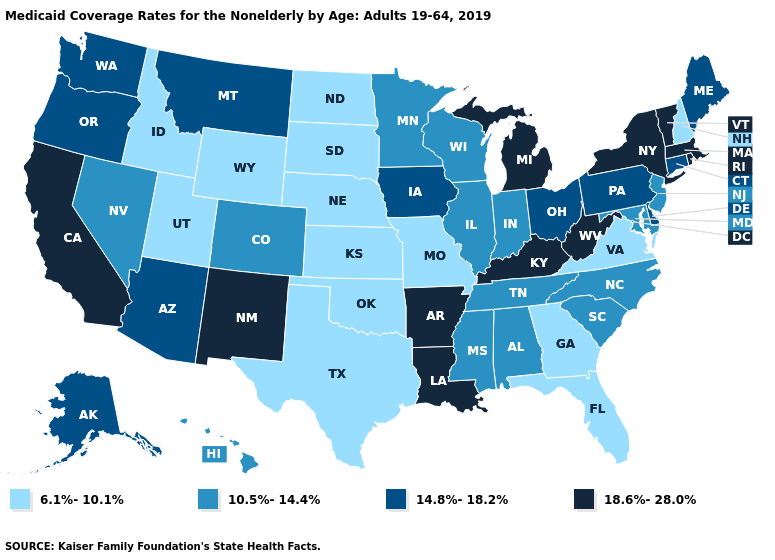Does Texas have the lowest value in the South?
Answer briefly. Yes. What is the highest value in the USA?
Answer briefly. 18.6%-28.0%. Name the states that have a value in the range 14.8%-18.2%?
Be succinct. Alaska, Arizona, Connecticut, Delaware, Iowa, Maine, Montana, Ohio, Oregon, Pennsylvania, Washington. What is the value of Pennsylvania?
Be succinct. 14.8%-18.2%. What is the highest value in the MidWest ?
Be succinct. 18.6%-28.0%. Name the states that have a value in the range 14.8%-18.2%?
Quick response, please. Alaska, Arizona, Connecticut, Delaware, Iowa, Maine, Montana, Ohio, Oregon, Pennsylvania, Washington. Does Alabama have a lower value than Kentucky?
Quick response, please. Yes. Which states have the highest value in the USA?
Give a very brief answer. Arkansas, California, Kentucky, Louisiana, Massachusetts, Michigan, New Mexico, New York, Rhode Island, Vermont, West Virginia. What is the value of Utah?
Answer briefly. 6.1%-10.1%. Does Vermont have a higher value than Louisiana?
Write a very short answer. No. Does Tennessee have the same value as Minnesota?
Quick response, please. Yes. Among the states that border Oklahoma , does New Mexico have the highest value?
Keep it brief. Yes. Among the states that border Nevada , does Idaho have the highest value?
Concise answer only. No. What is the value of New Hampshire?
Keep it brief. 6.1%-10.1%. 